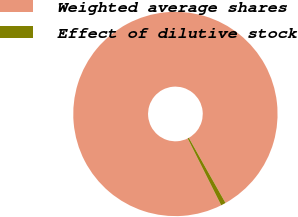Convert chart. <chart><loc_0><loc_0><loc_500><loc_500><pie_chart><fcel>Weighted average shares<fcel>Effect of dilutive stock<nl><fcel>99.23%<fcel>0.77%<nl></chart> 